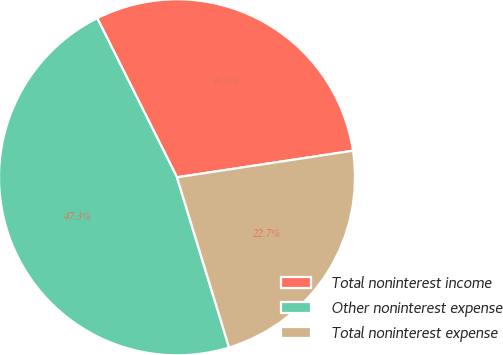Convert chart to OTSL. <chart><loc_0><loc_0><loc_500><loc_500><pie_chart><fcel>Total noninterest income<fcel>Other noninterest expense<fcel>Total noninterest expense<nl><fcel>30.01%<fcel>47.33%<fcel>22.66%<nl></chart> 